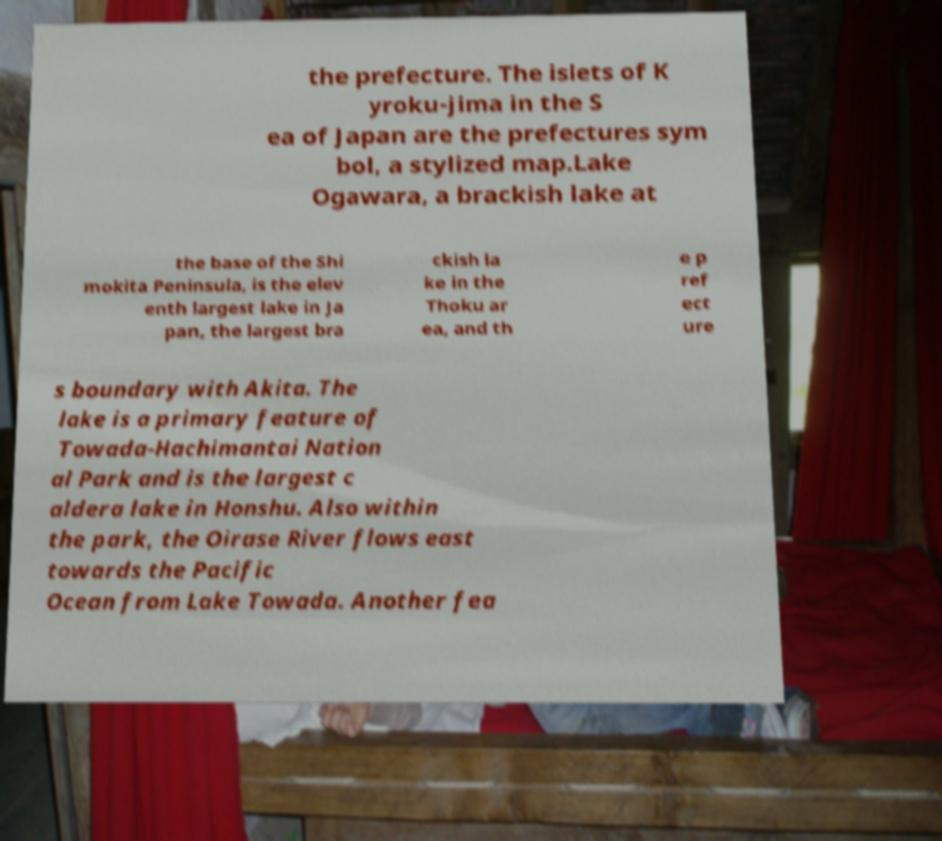I need the written content from this picture converted into text. Can you do that? the prefecture. The islets of K yroku-jima in the S ea of Japan are the prefectures sym bol, a stylized map.Lake Ogawara, a brackish lake at the base of the Shi mokita Peninsula, is the elev enth largest lake in Ja pan, the largest bra ckish la ke in the Thoku ar ea, and th e p ref ect ure s boundary with Akita. The lake is a primary feature of Towada-Hachimantai Nation al Park and is the largest c aldera lake in Honshu. Also within the park, the Oirase River flows east towards the Pacific Ocean from Lake Towada. Another fea 